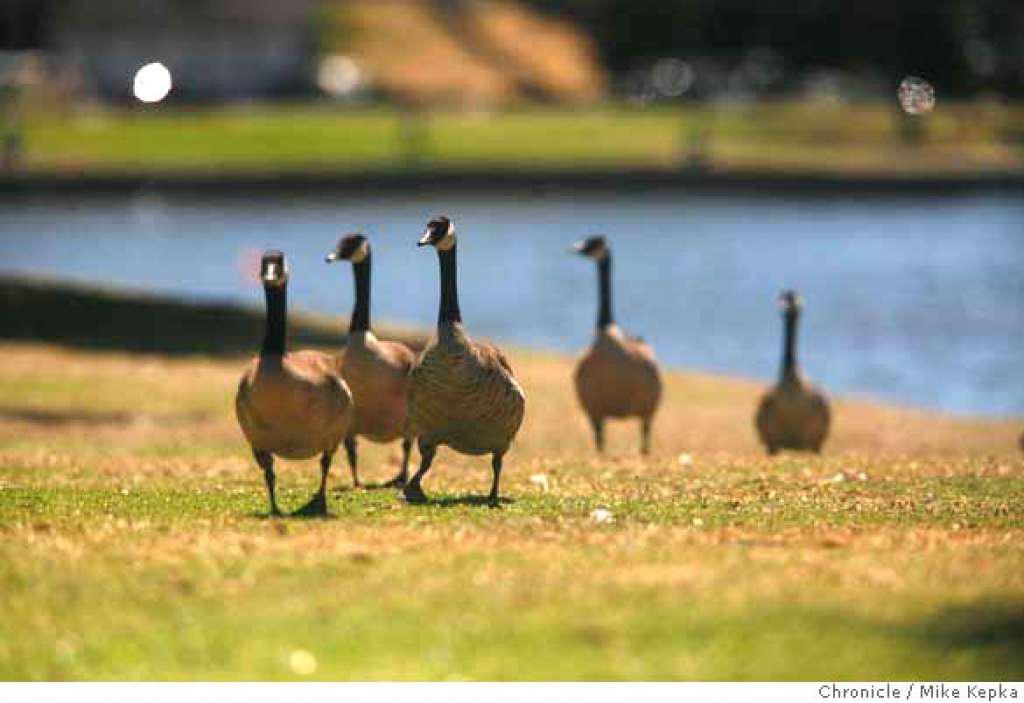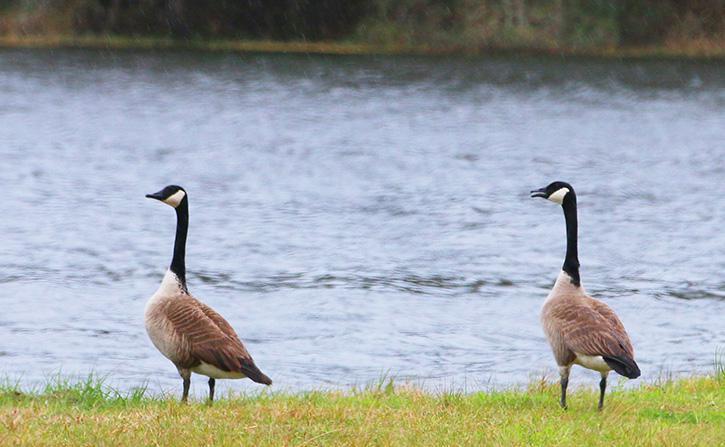The first image is the image on the left, the second image is the image on the right. Analyze the images presented: Is the assertion "In the right image, there are two Canadian geese." valid? Answer yes or no. Yes. The first image is the image on the left, the second image is the image on the right. Given the left and right images, does the statement "the image on the right has 2 geese" hold true? Answer yes or no. Yes. 